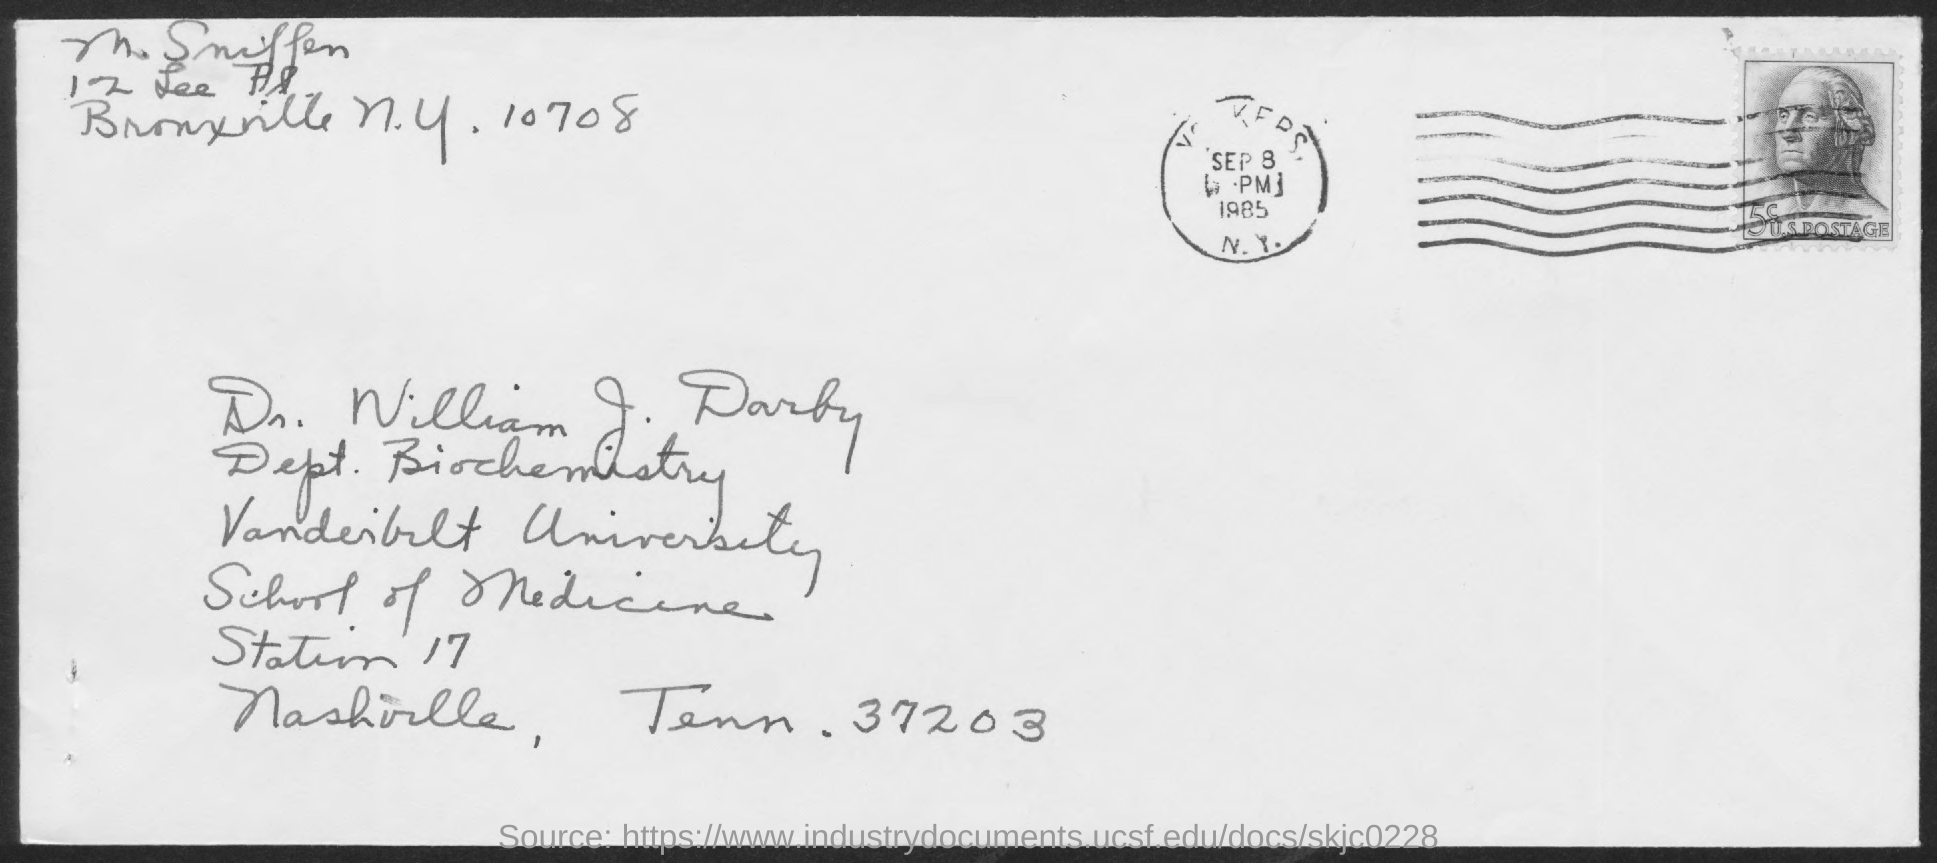Mention a couple of crucial points in this snapshot. Dr. William J. Darby, who is from Vanderbilt University, is mentioned in the address. 